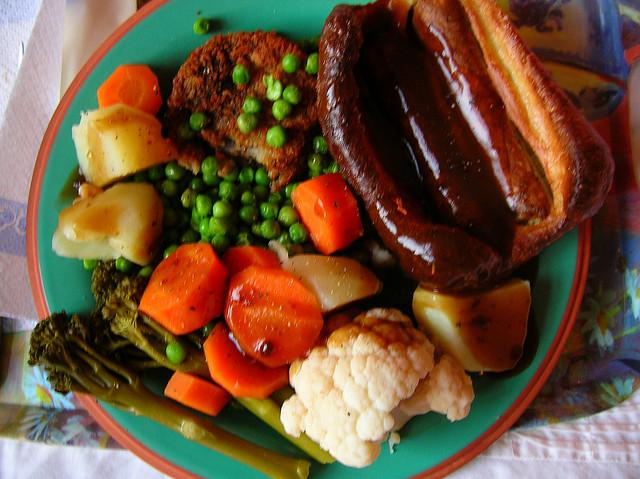Is the cauliflower on the edge of the plate?
Short answer required. Yes. Is the meal shown sufficient to feed an entire family?
Give a very brief answer. No. What type of meat is shown?
Give a very brief answer. Sausage. 